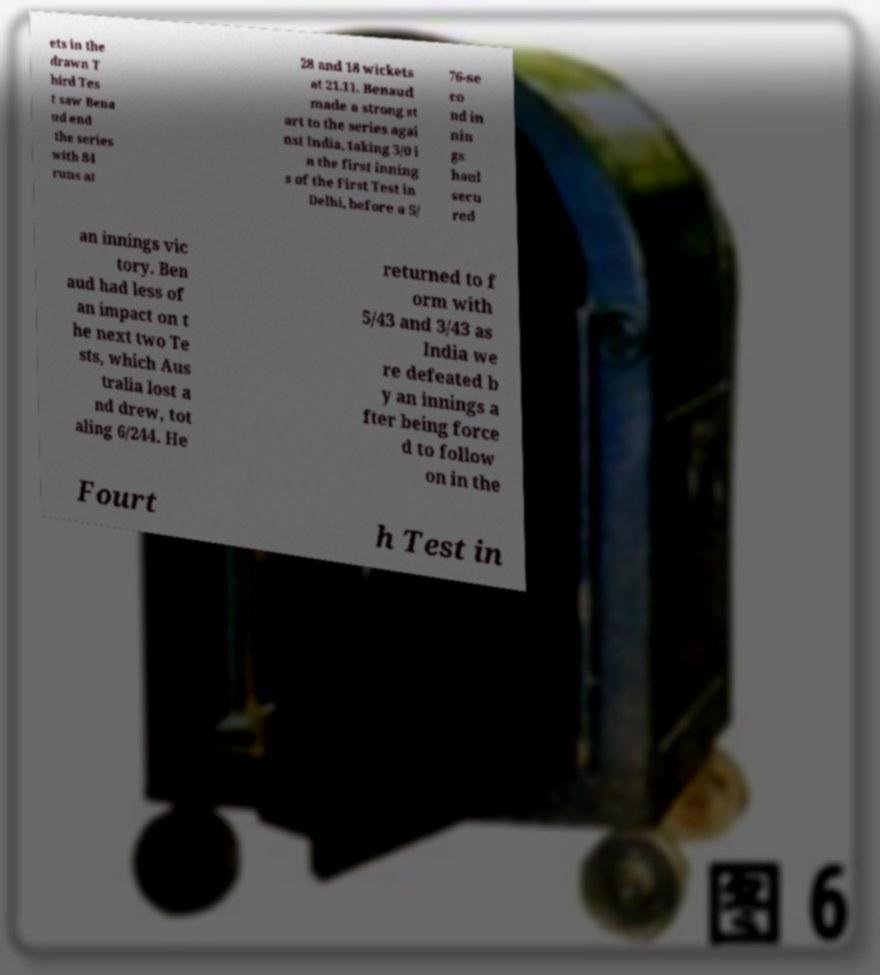I need the written content from this picture converted into text. Can you do that? ets in the drawn T hird Tes t saw Bena ud end the series with 84 runs at 28 and 18 wickets at 21.11. Benaud made a strong st art to the series agai nst India, taking 3/0 i n the first inning s of the First Test in Delhi, before a 5/ 76-se co nd in nin gs haul secu red an innings vic tory. Ben aud had less of an impact on t he next two Te sts, which Aus tralia lost a nd drew, tot aling 6/244. He returned to f orm with 5/43 and 3/43 as India we re defeated b y an innings a fter being force d to follow on in the Fourt h Test in 